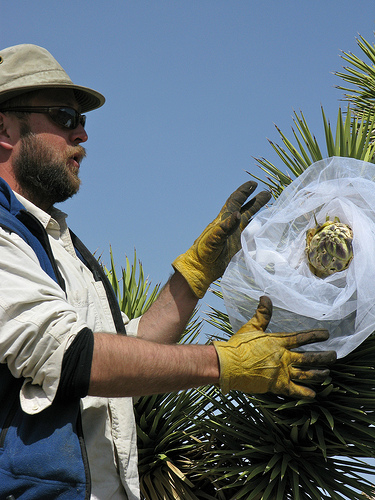<image>
Can you confirm if the man is on the cover? No. The man is not positioned on the cover. They may be near each other, but the man is not supported by or resting on top of the cover. 